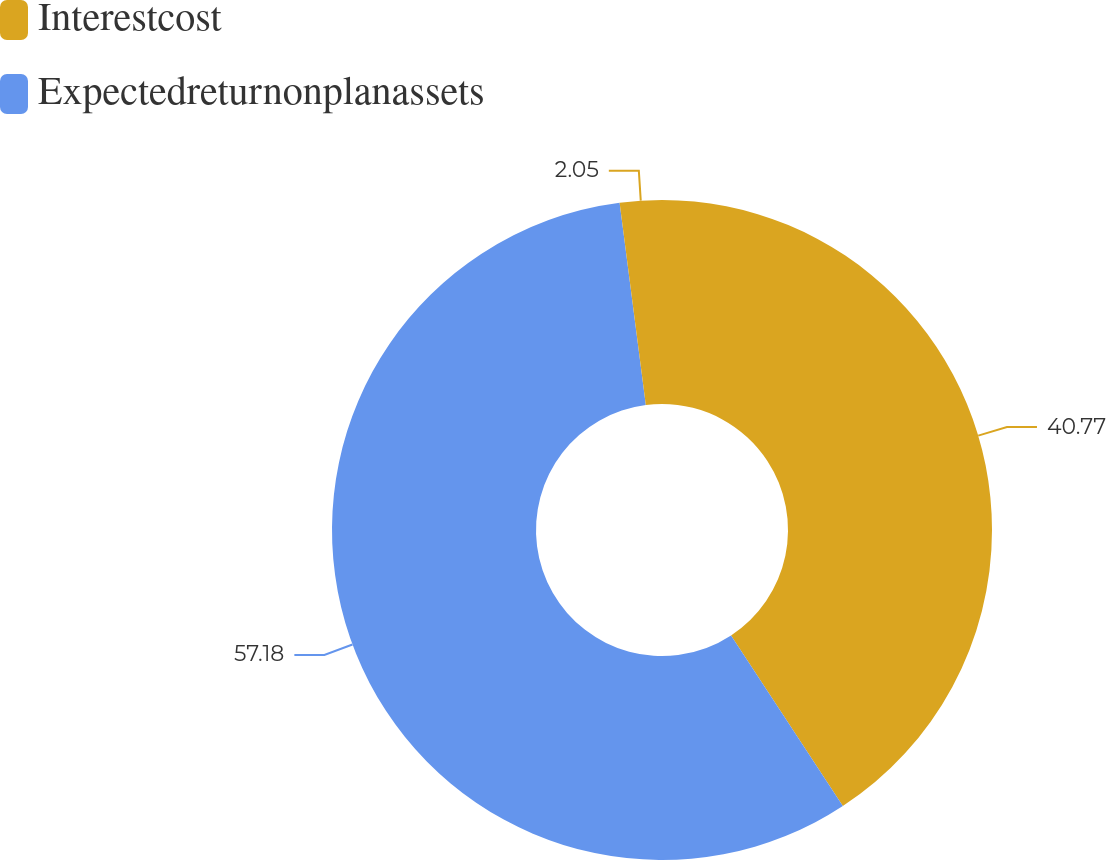<chart> <loc_0><loc_0><loc_500><loc_500><pie_chart><fcel>Interestcost<fcel>Expectedreturnonplanassets<fcel>Unnamed: 2<nl><fcel>40.77%<fcel>57.18%<fcel>2.05%<nl></chart> 